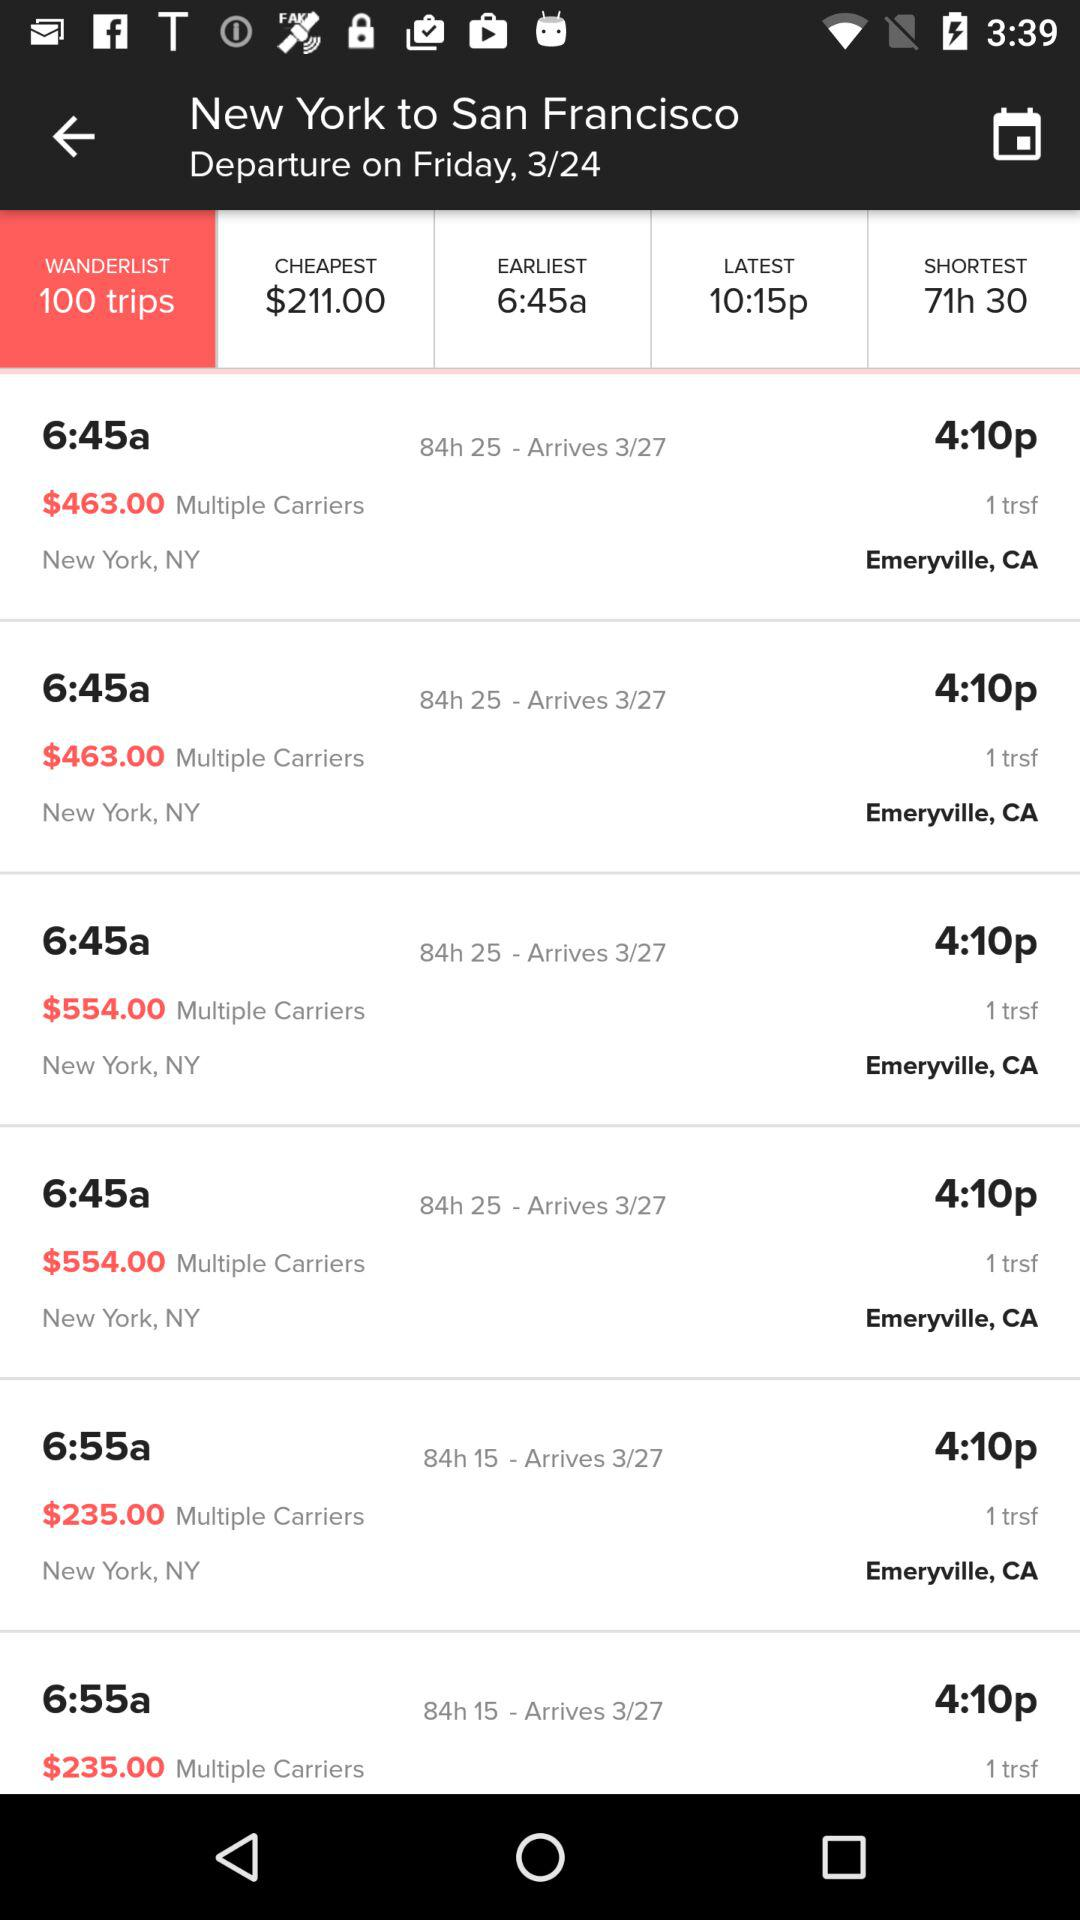What's the shortest duration of the flight? The shortest duration of the flight is 71 hours 30 minutes. 